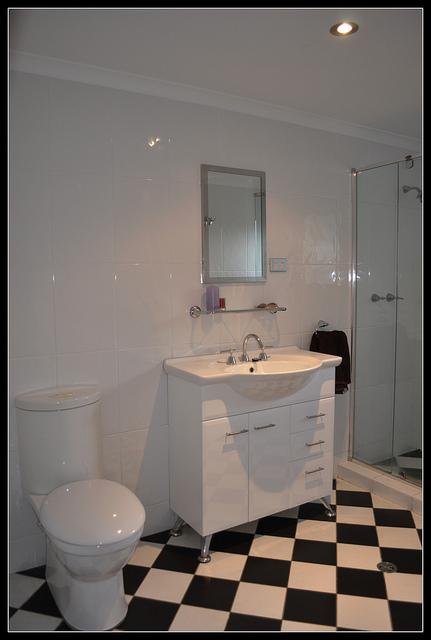What color are the bath towels?
Give a very brief answer. Black. What resembles the shape of a Stop Sign?
Write a very short answer. Tile. What pattern is on the toilet seat cover?
Short answer required. Solid. What color are the walls?
Quick response, please. White. Did they have a leak?
Answer briefly. No. What color is the toilet in this picture?
Give a very brief answer. White. What is wrong with the ceiling?
Keep it brief. Nothing. Is this toilet functional?
Answer briefly. Yes. How many televisions are in this room?
Keep it brief. 0. What color is the wall behind the shower head?
Keep it brief. White. Where is the tank flush handle?
Concise answer only. Top. Is the bathroom big?
Give a very brief answer. Yes. Is this bathroom well kept and functional?
Short answer required. Yes. What color is the tile?
Give a very brief answer. Black and white. How would you describe the current livability?
Concise answer only. Good. Is this a spacious room?
Quick response, please. Yes. What is hanging on the wall left of the mirror?
Answer briefly. Towel rack. Is there a shower curtain?
Short answer required. No. Is this a great bathroom?
Answer briefly. Yes. What color is the bathroom floor?
Short answer required. Black and white. Is there a mirror reflected in another mirror?
Short answer required. No. Can you see foliage in the reflection of the mirror?
Quick response, please. No. Is this a modern room?
Quick response, please. Yes. What is there a window in the bathroom?
Keep it brief. No. Is the room clean?
Concise answer only. Yes. Is there a reflection in the mirror?
Give a very brief answer. No. What is hanging on the wall?
Concise answer only. Mirror. What color is the counter?
Keep it brief. White. Are there any vents?
Answer briefly. No. Is there a skylight in the bathroom?
Write a very short answer. No. Is this a public bathroom?
Keep it brief. No. Is the toilet complete?
Concise answer only. Yes. Where is the light shining?
Quick response, please. Down. Is this area appear very messy?
Short answer required. No. Is this a public place?
Keep it brief. No. The item for removing water from wet hands has stripes. How many dark stripes are narrow?
Write a very short answer. 0. What color is the floor?
Short answer required. Black and white. Would a real estate person call this a full bathroom?
Keep it brief. Yes. What color is this bathroom?
Short answer required. White. Is the ceiling crumbling?
Short answer required. No. Does this room need to be remodeled?
Quick response, please. No. What is to the left of the sink?
Keep it brief. Toilet. What style do these floor tiles appear to be?
Be succinct. Checkerboard. Is the ceiling above the toilet slanted?
Concise answer only. No. Is this a discouraging sight?
Quick response, please. No. Are there eyeglasses on the counter?
Keep it brief. No. What is the design on the floor?
Keep it brief. Checkered. Is there a window in the bathroom?
Write a very short answer. No. Has the toilet been used?
Short answer required. No. Is this a nice bathroom?
Answer briefly. Yes. What is the source of light in the picture?
Answer briefly. Ceiling light. Is there a toilet here?
Keep it brief. Yes. Is this an old fashioned bathroom?
Quick response, please. No. What country is this likely to be located in?
Concise answer only. Usa. Is there a window above the toilet?
Short answer required. No. Where is the mirror?
Concise answer only. Above sink. Are the toilets located in a bathroom?
Write a very short answer. Yes. Is this a good place for a toilet?
Write a very short answer. Yes. Is this a private bathroom?
Answer briefly. Yes. Is there a towel on the rack?
Short answer required. Yes. Is there more than one towel?
Short answer required. No. Is the room built for children?
Short answer required. No. Is the wall rusted?
Be succinct. No. Is the mirror square?
Be succinct. No. Is this bathroom setup conventional?
Keep it brief. Yes. Is this a normal place for a toilette to be?
Short answer required. Yes. How many sinks are there?
Be succinct. 1. What color is the sink?
Short answer required. White. What color is the wall behind the toilet?
Answer briefly. White. What is white in the background?
Keep it brief. Wall. Are there any plants in this image?
Keep it brief. No. Where is the sink?
Give a very brief answer. Bathroom. Is the room in the picture clean or dirty?
Concise answer only. Clean. Is the bathroom clean?
Short answer required. Yes. What is the material of the floor?
Write a very short answer. Tile. How many rooms do you see?
Answer briefly. 1. Which room is this?
Write a very short answer. Bathroom. What is the date when the photo was taken?
Concise answer only. 2016. What kind of flooring in the room?
Answer briefly. Tile. Is the room big or small?
Keep it brief. Big. How many toilets are there?
Quick response, please. 1. What type of sink is this?
Short answer required. Bathroom. Does the tile floor have a pattern?
Be succinct. Yes. Is this a clean bathroom?
Answer briefly. Yes. What is on the ground?
Write a very short answer. Tile. What unique pattern is this?
Keep it brief. Checkered. What is the toilet being used for?
Write a very short answer. Bathroom. Are there any windows in the room?
Quick response, please. No. Is this room clean?
Write a very short answer. Yes. Is there a lid on the toilet?
Write a very short answer. Yes. How many rolls of toilet paper are visible?
Concise answer only. 0. Is there something to clean the toilet with?
Keep it brief. No. Is the toilet seat open?
Quick response, please. No. Is there a hardwood floor?
Concise answer only. No. Where is the bathtub?
Quick response, please. No bathtub. What color is the tile around the sink?
Be succinct. White and black. Is there a light in this room?
Short answer required. Yes. Are there any towels on the shelf?
Answer briefly. No. Is the woman taking a selfie?
Keep it brief. No. 